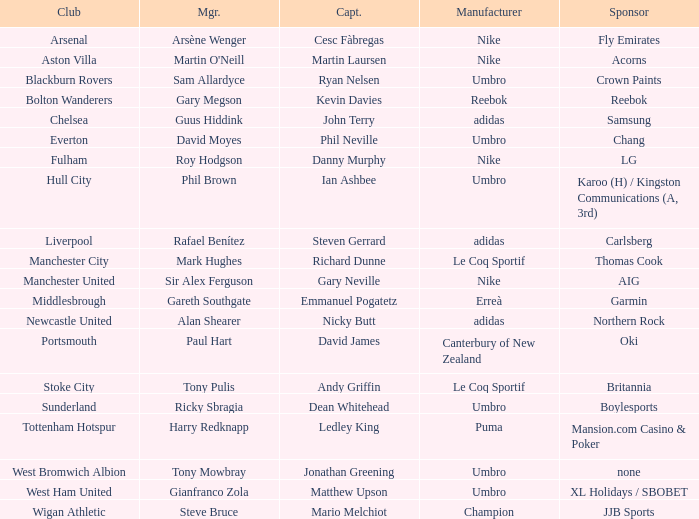What Premier League Manager has an Adidas sponsor and a Newcastle United club? Alan Shearer. 